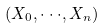<formula> <loc_0><loc_0><loc_500><loc_500>( X _ { 0 } , \cdot \cdot \cdot , X _ { n } )</formula> 